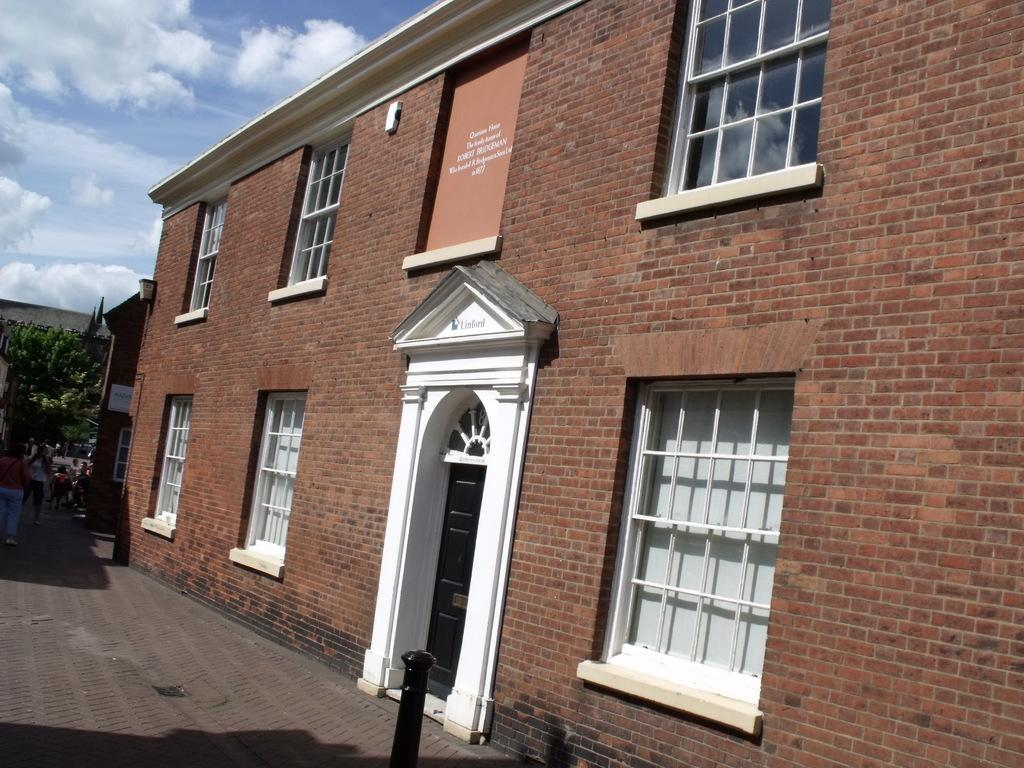What type of building is in the image? There is a brick building in the image. What features can be seen on the right side of the building? The building has doors and windows on the right side. What is happening on the left side of the image? There are people walking on the left side of the image. What can be seen in the background of the image? There are trees in the background of the image. What is visible above the image? The sky is visible above the image. What type of stitch is being used to repair the building in the image? There is no indication in the image that the building is being repaired, nor is there any mention of a stitch. 